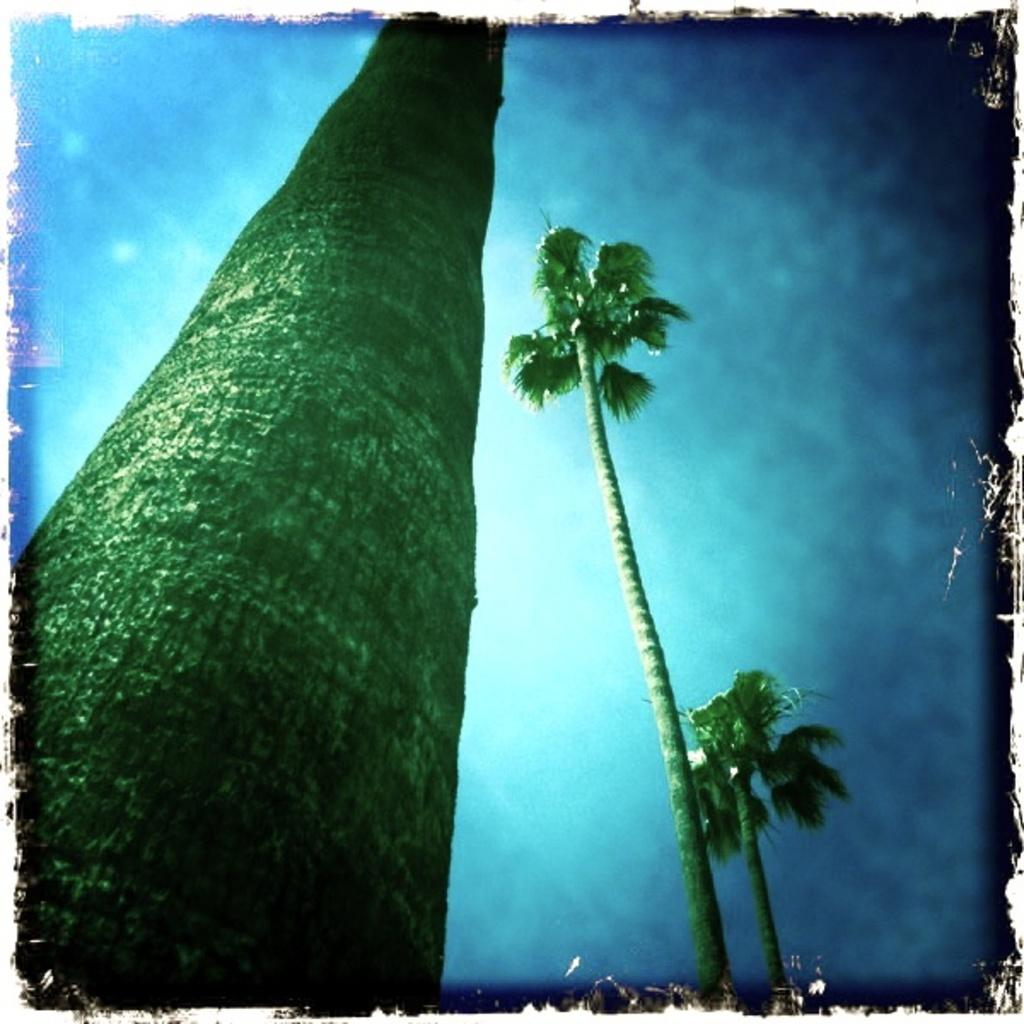What type of vegetation can be seen in the image? There are trees in the image. What part of the natural environment is visible in the image? The sky is visible in the background of the image. How many jellyfish can be seen swimming in the sky in the image? There are no jellyfish present in the image, and the sky is not depicted as a body of water where jellyfish could swim. 